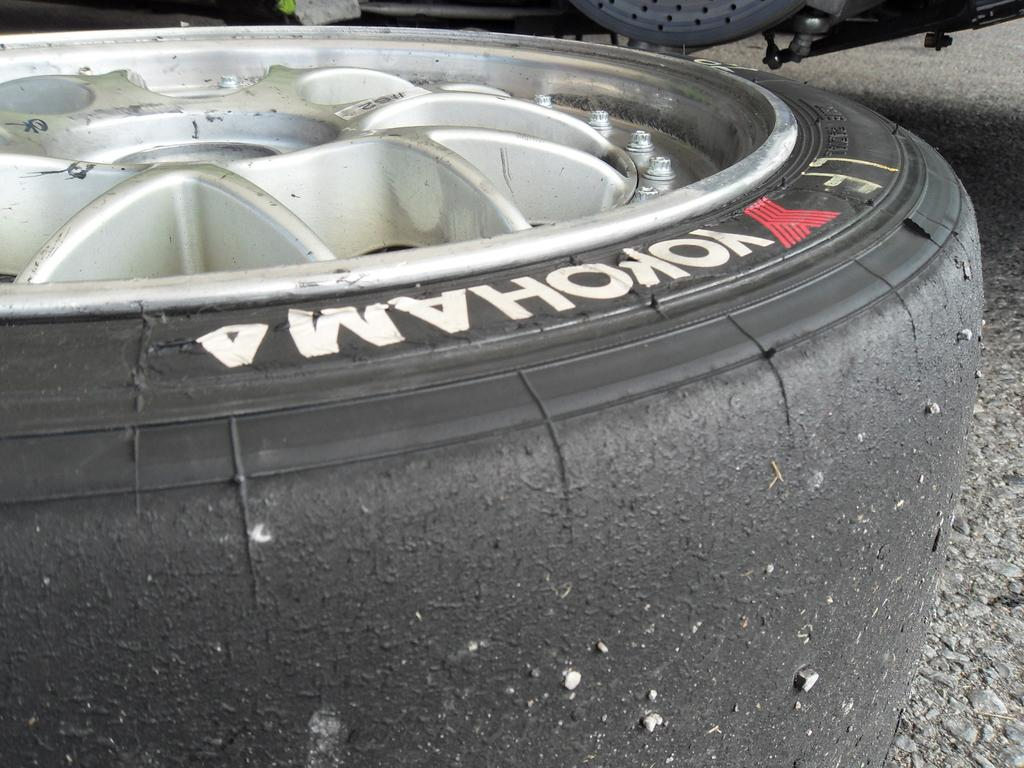What is the main object in the image? There is a tire with a rim in the image. Can you identify any branding on the tire? Yes, the name "YOKOHAMA" is visible on the tire. Where is the bear playing during recess in the image? There are no bears or recess depicted in the image; it features a tire with a rim and the name "YOKOHAMA" on it. 